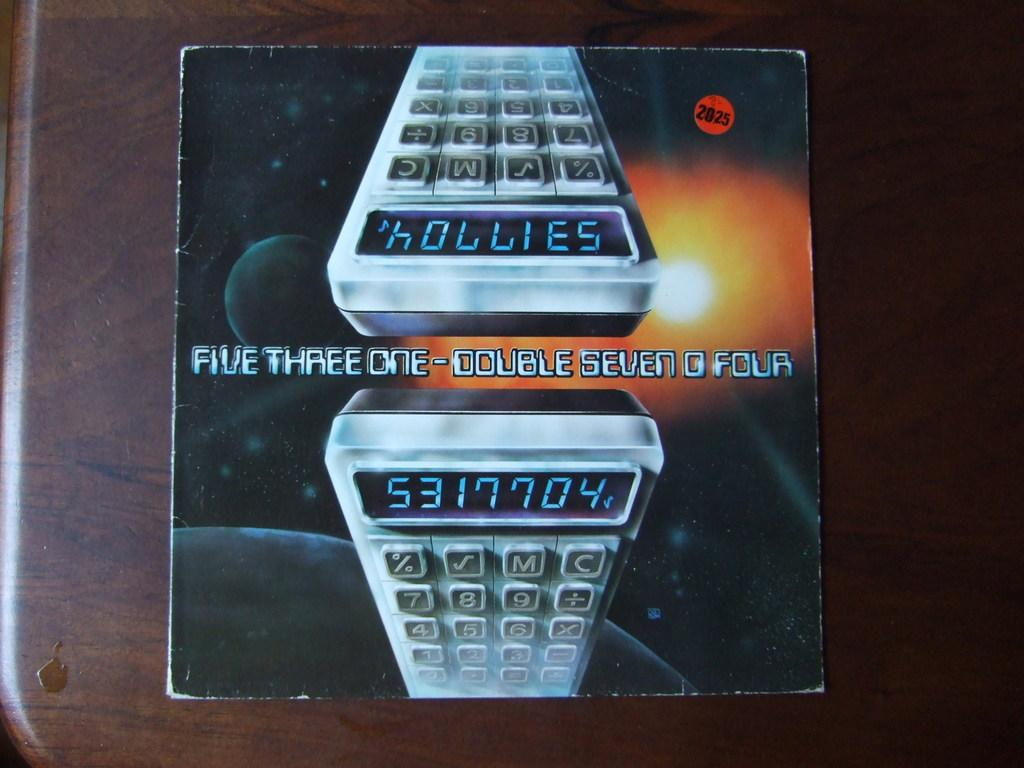What object is on the table in the image? There is a box on the table in the image. What is depicted on the box? The box has a picture of a device and the solar system. Are there any words on the box? Yes, there is text on the box. What type of clouds can be seen in the picture of the solar system on the box? There are no clouds depicted in the picture of the solar system on the box; it only shows the planets and their orbits. 